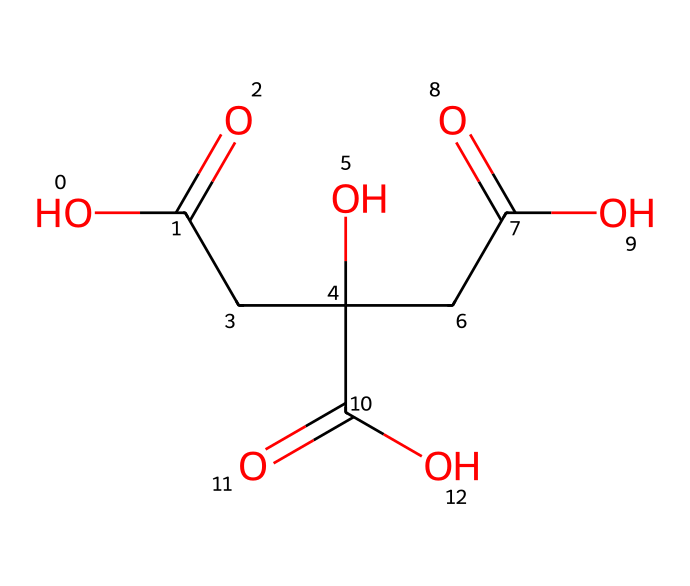how many carboxylic acid groups are present in citric acid? The SMILES representation shows multiple “C(=O)O” segments. Counting these segments reveals three carboxylic acid groups in the molecule.
Answer: three what is the functional group characteristic of citric acid? Citric acid contains carboxylic acid groups, which are identifiable by the presence of a carbon double-bonded to an oxygen atom and single-bonded to a hydroxyl group “-OH”.
Answer: carboxylic acid what is the molecular formula of citric acid? The chemical structure includes three carbon atoms from the main chain, with a total of six oxygen atoms from the carboxylic acid groups. The molecular formula derived from this is C6H8O7.
Answer: C6H8O7 which property of citric acid makes it effective for cleaning lenses? The acidic nature of citric acid allows it to dissolve mineral deposits and grime, enhancing its effectiveness as a cleaner for camera lenses.
Answer: acidity how many hydrogen atoms are in the citric acid molecule? By analyzing the structure, we can see that the carbon framework supports a total of eight hydrogen atoms, contributing to its molecular formula's balance.
Answer: eight is citric acid a natural or synthetic compound? Citric acid is naturally occurring, as it is found in various fruits, particularly citrus fruits.
Answer: natural 